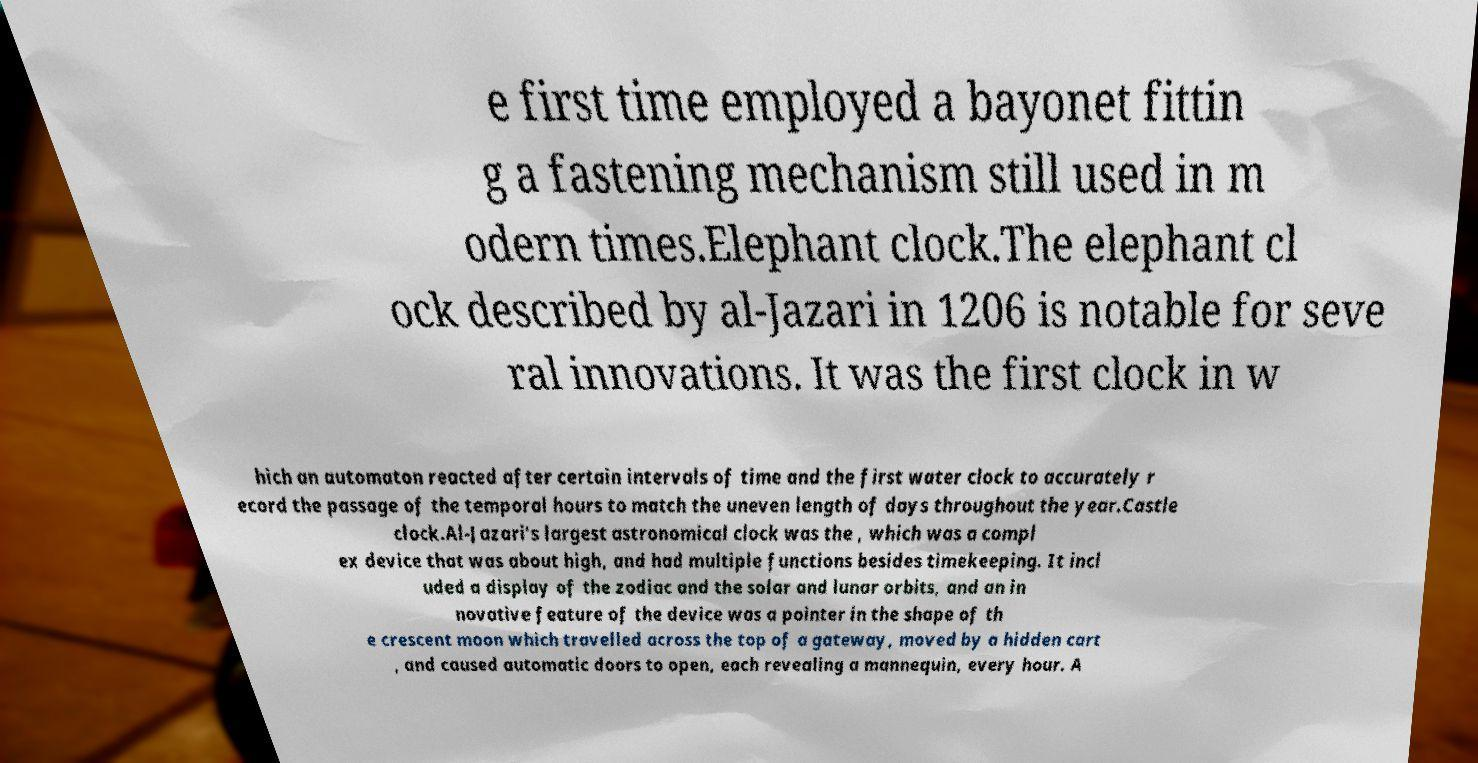For documentation purposes, I need the text within this image transcribed. Could you provide that? e first time employed a bayonet fittin g a fastening mechanism still used in m odern times.Elephant clock.The elephant cl ock described by al-Jazari in 1206 is notable for seve ral innovations. It was the first clock in w hich an automaton reacted after certain intervals of time and the first water clock to accurately r ecord the passage of the temporal hours to match the uneven length of days throughout the year.Castle clock.Al-Jazari's largest astronomical clock was the , which was a compl ex device that was about high, and had multiple functions besides timekeeping. It incl uded a display of the zodiac and the solar and lunar orbits, and an in novative feature of the device was a pointer in the shape of th e crescent moon which travelled across the top of a gateway, moved by a hidden cart , and caused automatic doors to open, each revealing a mannequin, every hour. A 